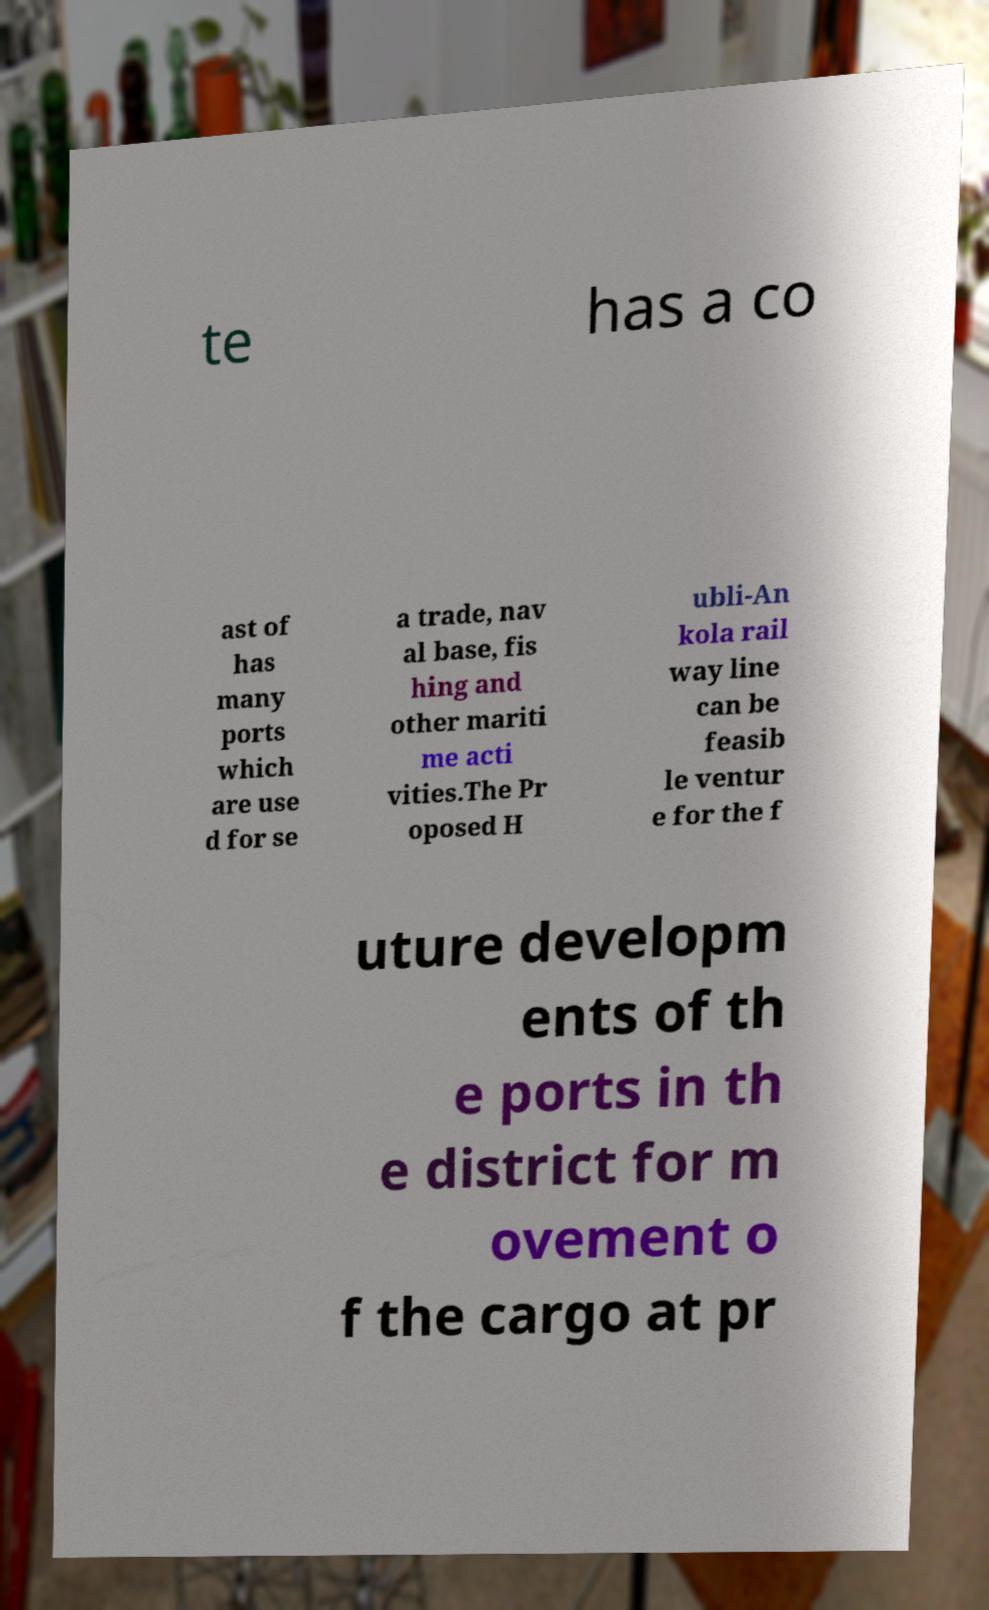Can you accurately transcribe the text from the provided image for me? te has a co ast of has many ports which are use d for se a trade, nav al base, fis hing and other mariti me acti vities.The Pr oposed H ubli-An kola rail way line can be feasib le ventur e for the f uture developm ents of th e ports in th e district for m ovement o f the cargo at pr 